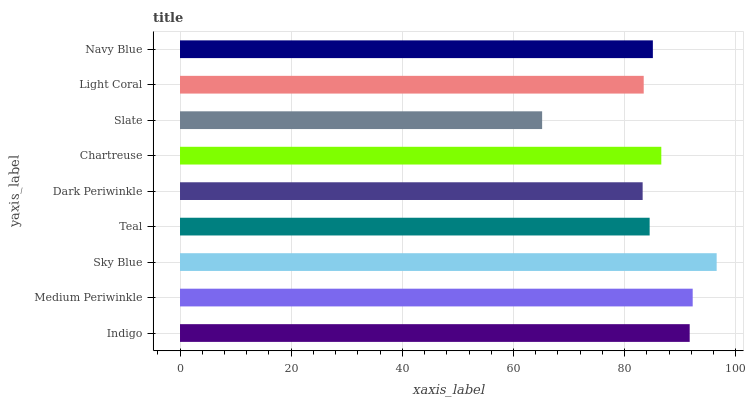Is Slate the minimum?
Answer yes or no. Yes. Is Sky Blue the maximum?
Answer yes or no. Yes. Is Medium Periwinkle the minimum?
Answer yes or no. No. Is Medium Periwinkle the maximum?
Answer yes or no. No. Is Medium Periwinkle greater than Indigo?
Answer yes or no. Yes. Is Indigo less than Medium Periwinkle?
Answer yes or no. Yes. Is Indigo greater than Medium Periwinkle?
Answer yes or no. No. Is Medium Periwinkle less than Indigo?
Answer yes or no. No. Is Navy Blue the high median?
Answer yes or no. Yes. Is Navy Blue the low median?
Answer yes or no. Yes. Is Slate the high median?
Answer yes or no. No. Is Chartreuse the low median?
Answer yes or no. No. 